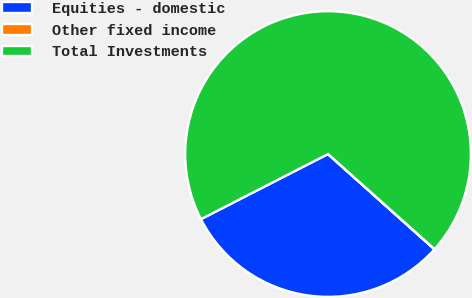Convert chart to OTSL. <chart><loc_0><loc_0><loc_500><loc_500><pie_chart><fcel>Equities - domestic<fcel>Other fixed income<fcel>Total Investments<nl><fcel>30.84%<fcel>0.03%<fcel>69.13%<nl></chart> 